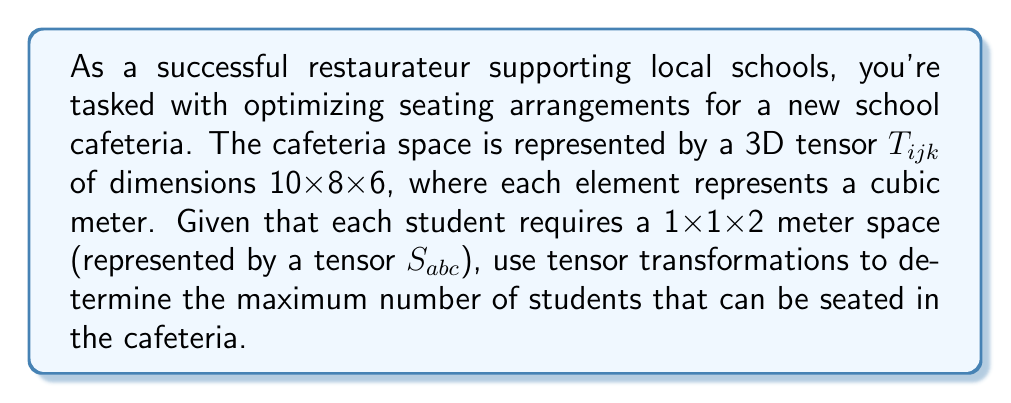Give your solution to this math problem. 1. First, we need to define our tensors:
   - Cafeteria space: $T_{ijk}$ (10x8x6)
   - Student space: $S_{abc}$ (1x1x2)

2. To find the maximum number of students, we need to perform a tensor convolution operation. This operation will slide the student tensor over the cafeteria tensor and count the number of valid positions.

3. The resulting tensor $R_{pqr}$ will have dimensions:
   $$R_{pqr}: (10-1+1) \times (8-1+1) \times (6-2+1) = 10 \times 8 \times 5$$

4. The convolution operation can be expressed as:
   $$R_{pqr} = \sum_{i=0}^{1}\sum_{j=0}^{1}\sum_{k=0}^{2} T_{p+i,q+j,r+k} \cdot S_{ijk}$$

5. Each element in $R_{pqr}$ that equals 1 represents a valid seating position.

6. To get the total number of valid seating positions, we sum all elements of $R_{pqr}$:
   $$\text{Total seats} = \sum_{p=0}^{9}\sum_{q=0}^{7}\sum_{r=0}^{4} R_{pqr}$$

7. Given the dimensions, we can calculate this without actually performing the convolution:
   $$\text{Total seats} = 10 \times 8 \times 5 = 400$$

This represents the maximum number of students that can be seated in the cafeteria space.
Answer: 400 students 